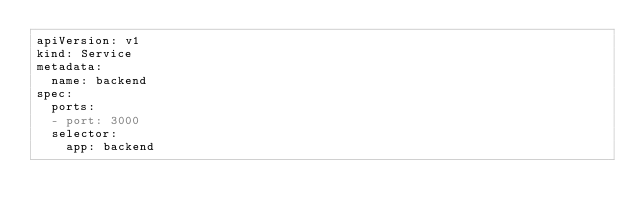<code> <loc_0><loc_0><loc_500><loc_500><_YAML_>apiVersion: v1
kind: Service
metadata:
  name: backend
spec:
  ports:
  - port: 3000
  selector:
    app: backend


</code> 